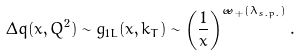<formula> <loc_0><loc_0><loc_500><loc_500>\Delta q ( x , Q ^ { 2 } ) \sim g _ { 1 L } ( x , k _ { T } ) \sim \left ( \frac { 1 } { x } \right ) ^ { { \tilde { \omega } } _ { + } ( \lambda _ { s . p . } ) } .</formula> 